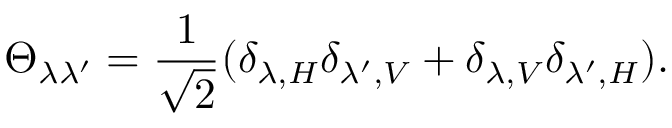<formula> <loc_0><loc_0><loc_500><loc_500>\Theta _ { \lambda \lambda ^ { \prime } } = \frac { 1 } { \sqrt { 2 } } ( \delta _ { \lambda , H } \delta _ { \lambda ^ { \prime } , V } + \delta _ { \lambda , V } \delta _ { \lambda ^ { \prime } , H } ) .</formula> 